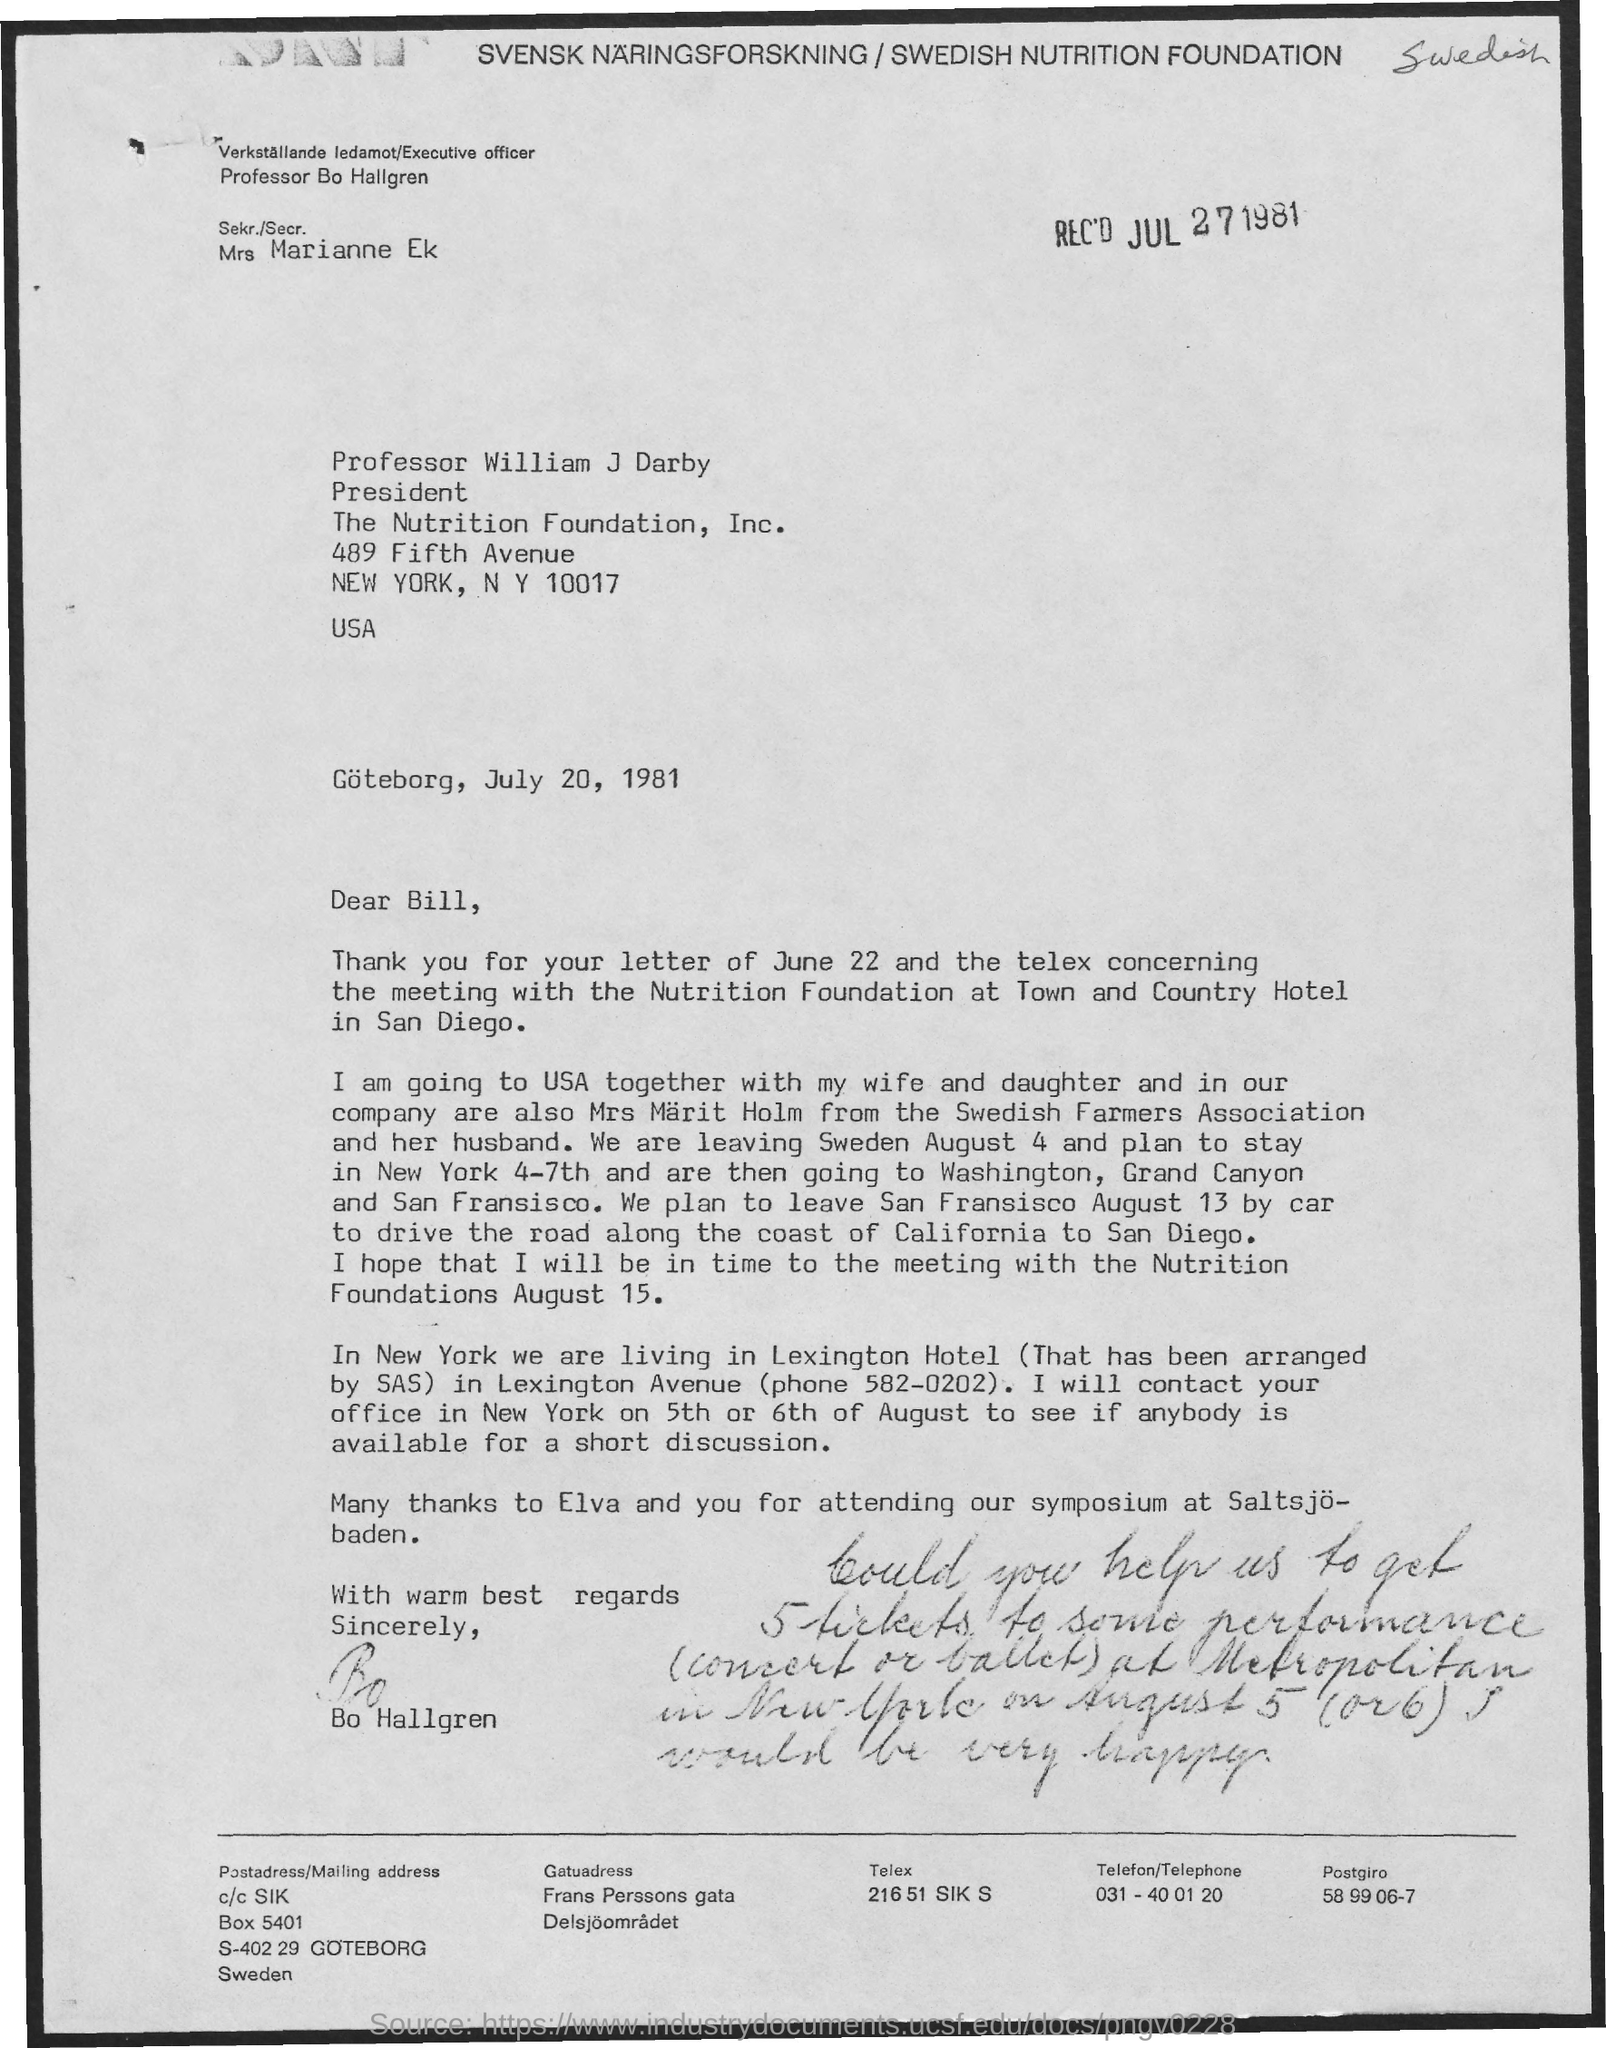Who has signed the letter?
Ensure brevity in your answer.  Bo hallgren. What is the received date of this letter?
Provide a short and direct response. JUL 27 1981. What is the Phone No of Lexington Avenue?
Provide a short and direct response. 582-0202. 